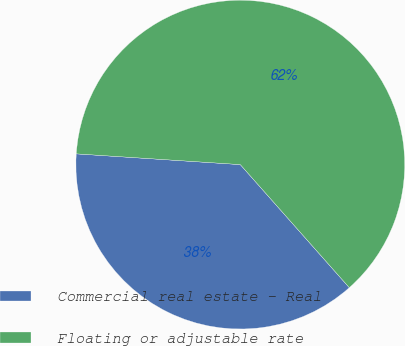<chart> <loc_0><loc_0><loc_500><loc_500><pie_chart><fcel>Commercial real estate - Real<fcel>Floating or adjustable rate<nl><fcel>37.58%<fcel>62.42%<nl></chart> 